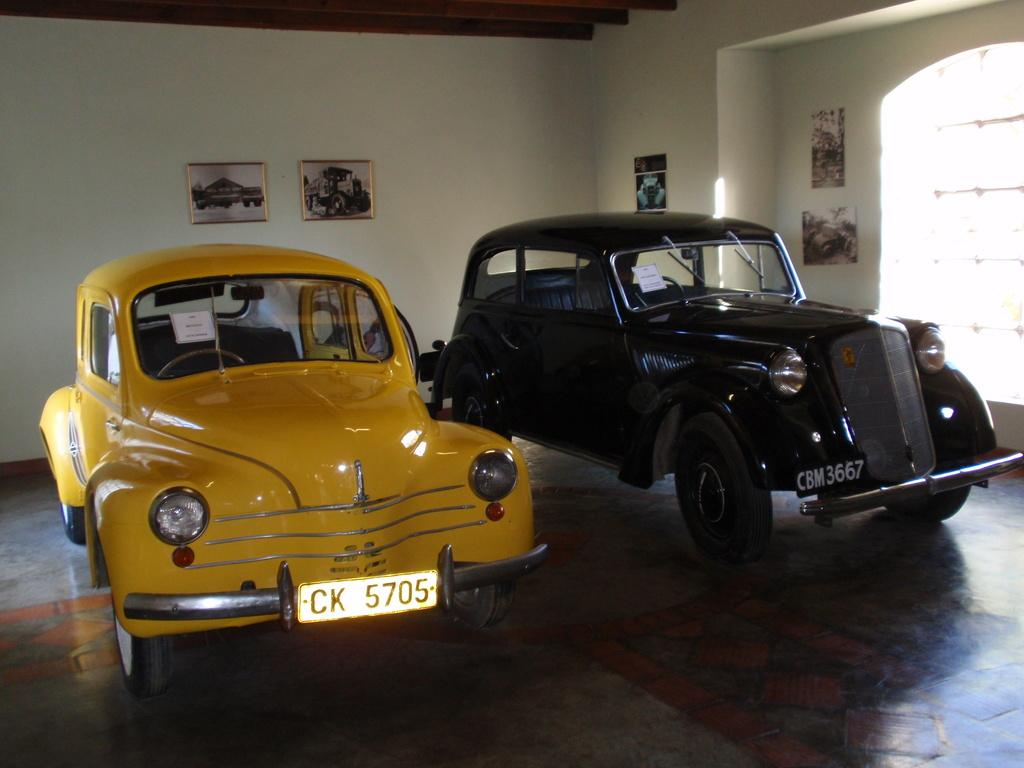How many cars are visible in the image? There are two cars in the image. What is the position of the cars in the image? The cars are parked on the ground. What are the colors of the cars in the image? One car is yellow, and the other is black. What can be seen on the wall in the background of the image? There are photo frames on the wall in the background. What type of leaf is used as a prop in the image? There is no leaf present in the image. What kind of prose is written on the car windows? There is no prose written on the car windows in the image. 